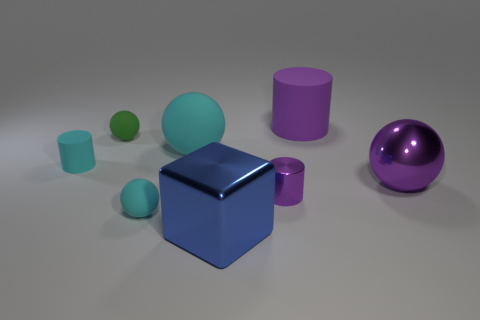Can you describe the lighting and atmosphere in this image? The lighting in this image is soft and diffuse, with a gentle shadow casting beneath each object, suggesting an evenly lit environment. The atmosphere is quite neutral and calm, with a clean, uncluttered background that doesn't detract from the focus on the shapes and their materials. 